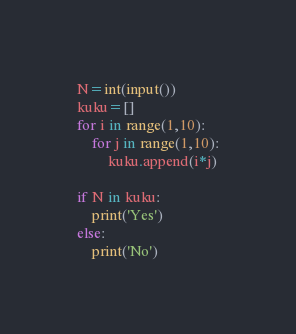<code> <loc_0><loc_0><loc_500><loc_500><_Python_>N=int(input())
kuku=[]
for i in range(1,10):
    for j in range(1,10):
        kuku.append(i*j)

if N in kuku:
    print('Yes')
else:
    print('No')</code> 